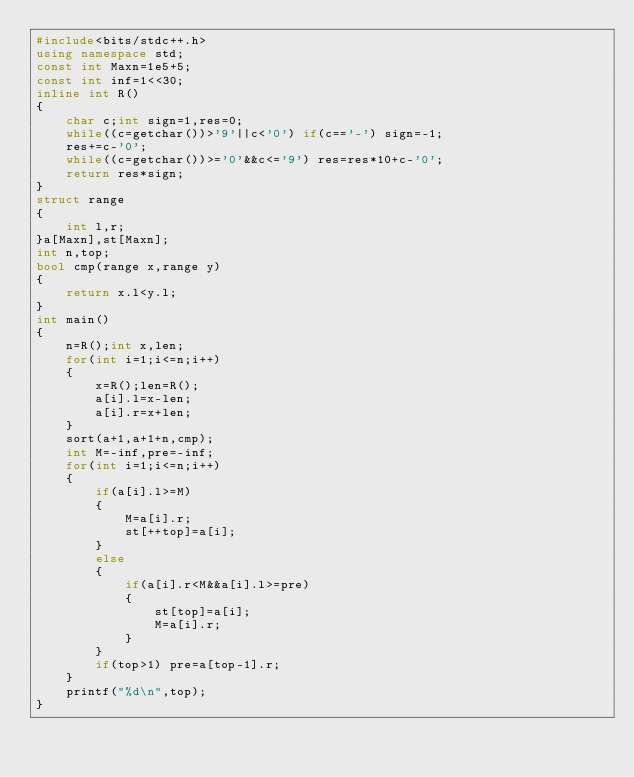Convert code to text. <code><loc_0><loc_0><loc_500><loc_500><_C++_>#include<bits/stdc++.h>
using namespace std;
const int Maxn=1e5+5;
const int inf=1<<30;
inline int R()
{
	char c;int sign=1,res=0;
	while((c=getchar())>'9'||c<'0') if(c=='-') sign=-1;
	res+=c-'0';
	while((c=getchar())>='0'&&c<='9') res=res*10+c-'0';
	return res*sign;	
}
struct range
{
	int l,r;
}a[Maxn],st[Maxn];
int n,top;
bool cmp(range x,range y)
{
	return x.l<y.l;
}
int main()
{
	n=R();int x,len;
	for(int i=1;i<=n;i++)
	{
		x=R();len=R();
		a[i].l=x-len;
		a[i].r=x+len;
	}
	sort(a+1,a+1+n,cmp);
	int M=-inf,pre=-inf;
	for(int i=1;i<=n;i++)
	{
		if(a[i].l>=M)
		{
			M=a[i].r;
			st[++top]=a[i];
		}
		else 
		{
			if(a[i].r<M&&a[i].l>=pre)
			{
				st[top]=a[i];
				M=a[i].r;
			}
		}
		if(top>1) pre=a[top-1].r;
	} 
	printf("%d\n",top);
}</code> 